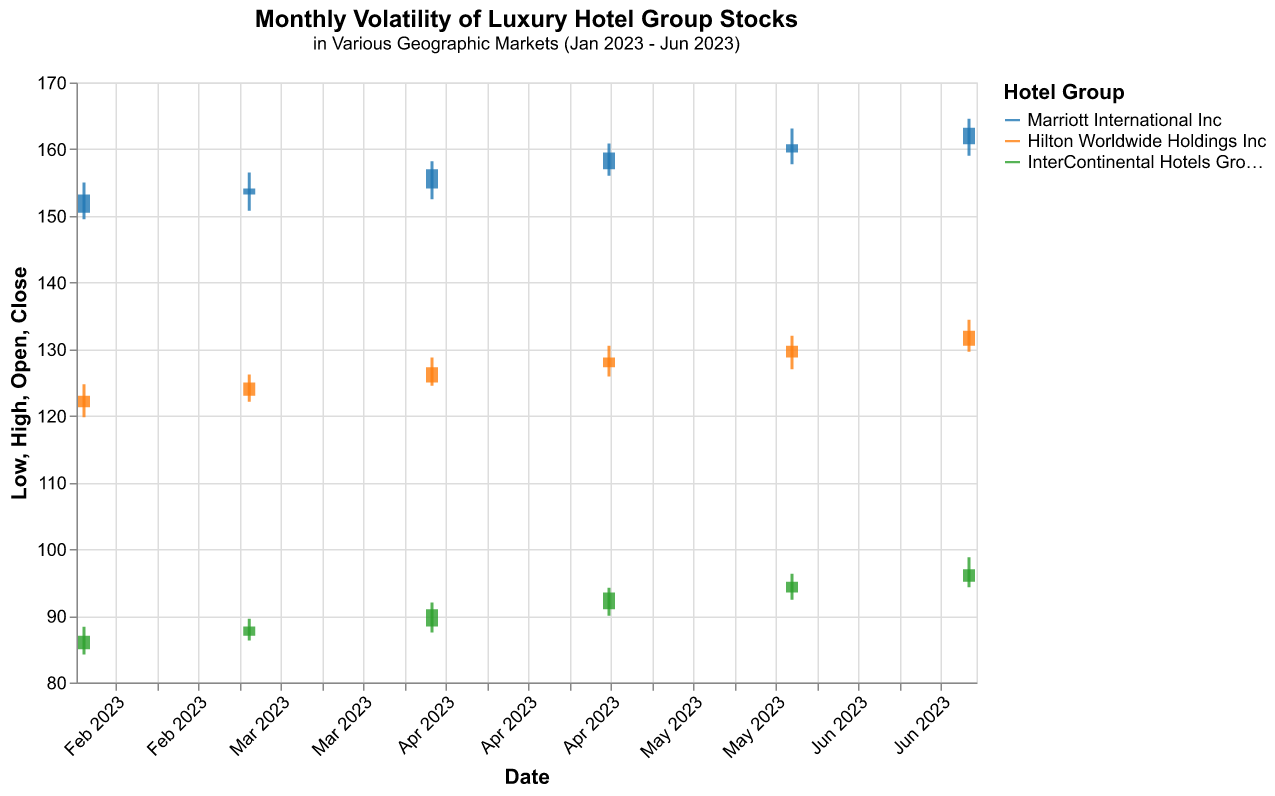What's the title of the figure? The title is usually displayed at the top of the figure. In this case, it states "Monthly Volatility of Luxury Hotel Group Stocks" and is subtitled "in Various Geographic Markets (Jan 2023 - Jun 2023)."
Answer: Monthly Volatility of Luxury Hotel Group Stocks How is the stock performance of Marriott International Inc. in North America for February 2023? Find Marriott International Inc.'s data for February 2023: Date: 2023-02-28. The open price is 153.20, high is 156.50, low is 150.75, and close is 154.10. All these values indicate stock performance.
Answer: Open: 153.20, High: 156.50, Low: 150.75, Close: 154.10 Which hotel group had the highest stock price in June 2023 in Asia-Pacific? Look for the data points dated June 2023 and check the high prices of hotel groups in Asia-Pacific. InterContinental Hotels Group PLC had the highest price, which is 98.80.
Answer: InterContinental Hotels Group PLC with a high price of 98.80 Did Marriott International Inc. stock price increase from January 2023 to June 2023? Compare the closing prices for Marriott International Inc. in January (153.20) and June (163.20). Since 163.20 is higher than 153.20, the price increased.
Answer: Yes Which hotel group had the lowest stock price in May 2023 in Europe? Look for data points in May 2023 and check the low prices of hotel groups in Europe. Hilton Worldwide Holdings Inc had the lowest price of 127.00.
Answer: Hilton Worldwide Holdings Inc with a low price of 127.00 What's the average closing price of Hilton Worldwide Holdings Inc. in Europe from January to June 2023? Sum up the closing prices for Hilton Worldwide Holdings Inc. in Europe: (123.00 + 125.00 + 127.30 + 128.75 + 130.50 + 132.75) and divide by 6. The sum is 767.30, so the average is 767.30 / 6 = 127.88.
Answer: 127.88 Which hotel had the highest monthly trading volume, and when did it occur? Search through the "Volume" data for the highest value and note the associated hotel and date. Marriott International Inc. had the highest volume with 155000 in June 2023.
Answer: Marriott International Inc. in June 2023 How many hotel groups are represented in the figure? Count the distinct hotel groups listed in the data: Marriott International Inc, Hilton Worldwide Holdings Inc, InterContinental Hotels Group PLC. There are 3 hotel groups.
Answer: 3 Which month had the highest volatility (difference between high and low) for InterContinental Hotels Group PLC in Asia-Pacific, and what was the value? Calculate the difference between high and low for each month for InterContinental Hotels Group PLC: Highest difference found in June 2023 is 98.80 - 94.30 = 4.50.
Answer: June 2023 with a volatility of 4.50 What is the overall trend in the closing prices of InterContinental Hotels Group PLC in Asia-Pacific from January to June 2023? List the closing prices for InterContinental Hotels Group PLC: 87.00, 88.40, 91.00, 93.50, 95.10, 97.00. Observe the increasing trend over the months.
Answer: Increasing 